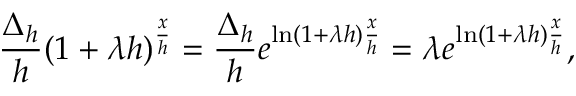Convert formula to latex. <formula><loc_0><loc_0><loc_500><loc_500>{ \frac { \Delta _ { h } } { h } } ( 1 + \lambda h ) ^ { \frac { x } { h } } = { \frac { \Delta _ { h } } { h } } e ^ { \ln ( 1 + \lambda h ) { \frac { x } { h } } } = \lambda e ^ { \ln ( 1 + \lambda h ) { \frac { x } { h } } } ,</formula> 